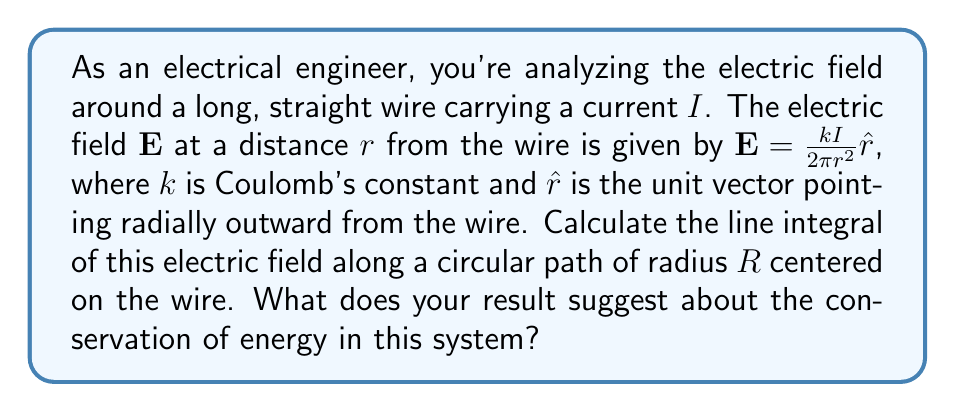Can you solve this math problem? Let's approach this step-by-step:

1) The line integral we need to compute is:

   $$\oint_C \mathbf{E} \cdot d\mathbf{l}$$

   where $C$ is the circular path of radius $R$.

2) We're given that $\mathbf{E} = \frac{kI}{2\pi r^2}\hat{r}$. On our circular path, $r = R$ (constant).

3) For a circular path, $d\mathbf{l} = R d\theta \hat{\theta}$, where $\hat{\theta}$ is the unit vector tangent to the circle.

4) The dot product $\mathbf{E} \cdot d\mathbf{l}$ is zero because $\hat{r}$ and $\hat{\theta}$ are perpendicular.

5) Therefore, at every point on the path:

   $$\mathbf{E} \cdot d\mathbf{l} = \frac{kI}{2\pi R^2}\hat{r} \cdot R d\theta \hat{\theta} = 0$$

6) The line integral is thus:

   $$\oint_C \mathbf{E} \cdot d\mathbf{l} = \int_0^{2\pi} 0 \, d\theta = 0$$

7) This result suggests that the electric field is conservative. The work done in moving a charge around a closed path in this field is zero, which is consistent with the conservation of energy in electrostatic systems.
Answer: The line integral of the electric field along the circular path is 0. This indicates that the electric field is conservative, consistent with the principle of conservation of energy in electrostatic systems. 